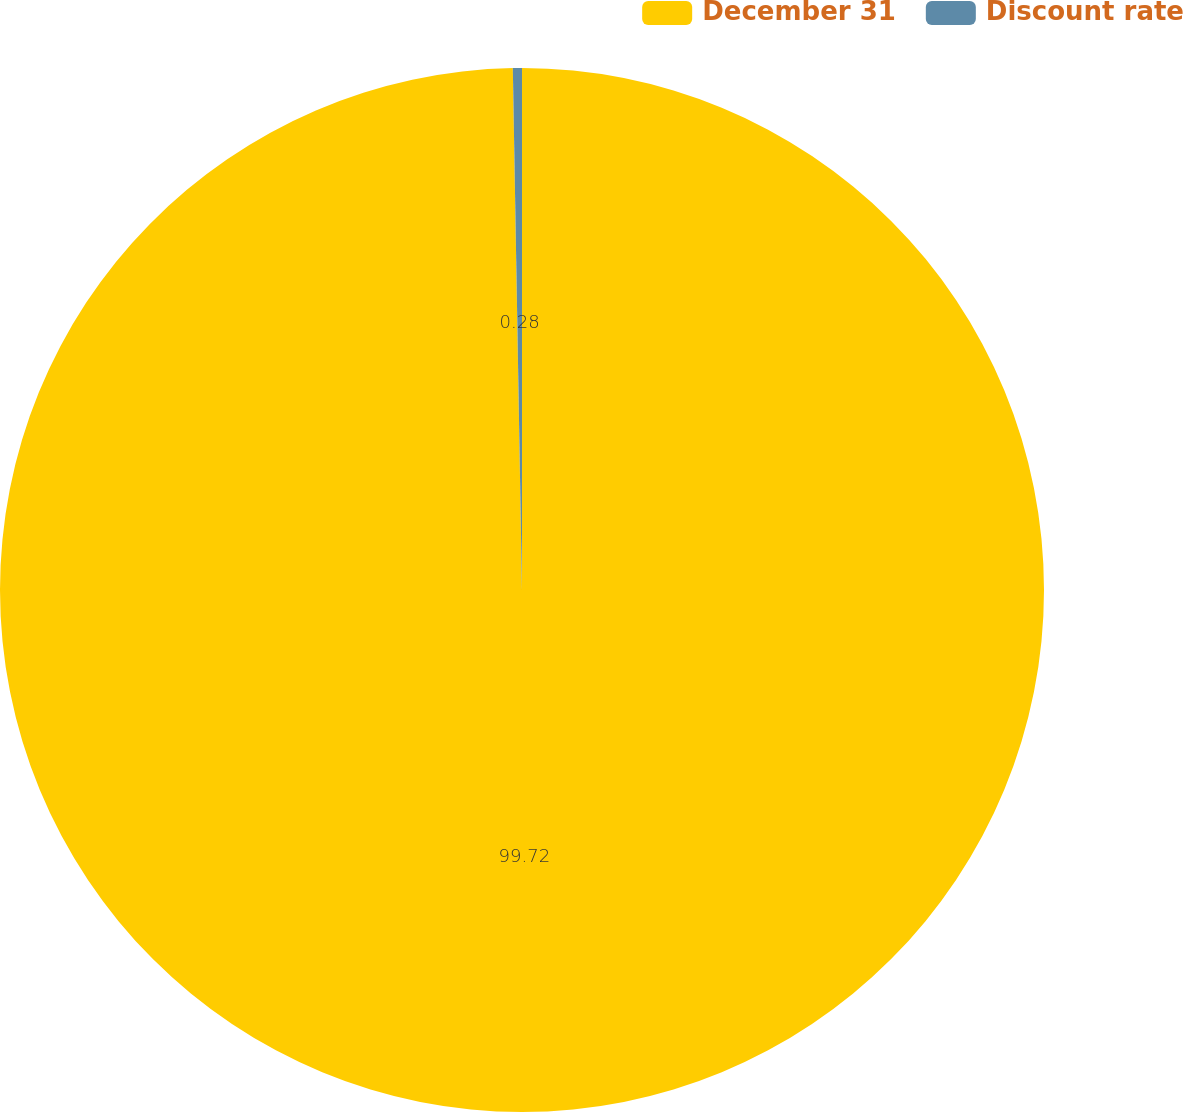<chart> <loc_0><loc_0><loc_500><loc_500><pie_chart><fcel>December 31<fcel>Discount rate<nl><fcel>99.72%<fcel>0.28%<nl></chart> 